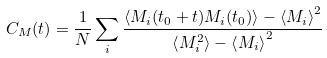<formula> <loc_0><loc_0><loc_500><loc_500>C _ { M } ( t ) = \frac { 1 } { N } \sum _ { i } \frac { \left < M _ { i } ( t _ { 0 } + t ) M _ { i } ( t _ { 0 } ) \right > - \left < M _ { i } \right > ^ { 2 } } { \left < M _ { i } ^ { 2 } \right > - \left < M _ { i } \right > ^ { 2 } }</formula> 